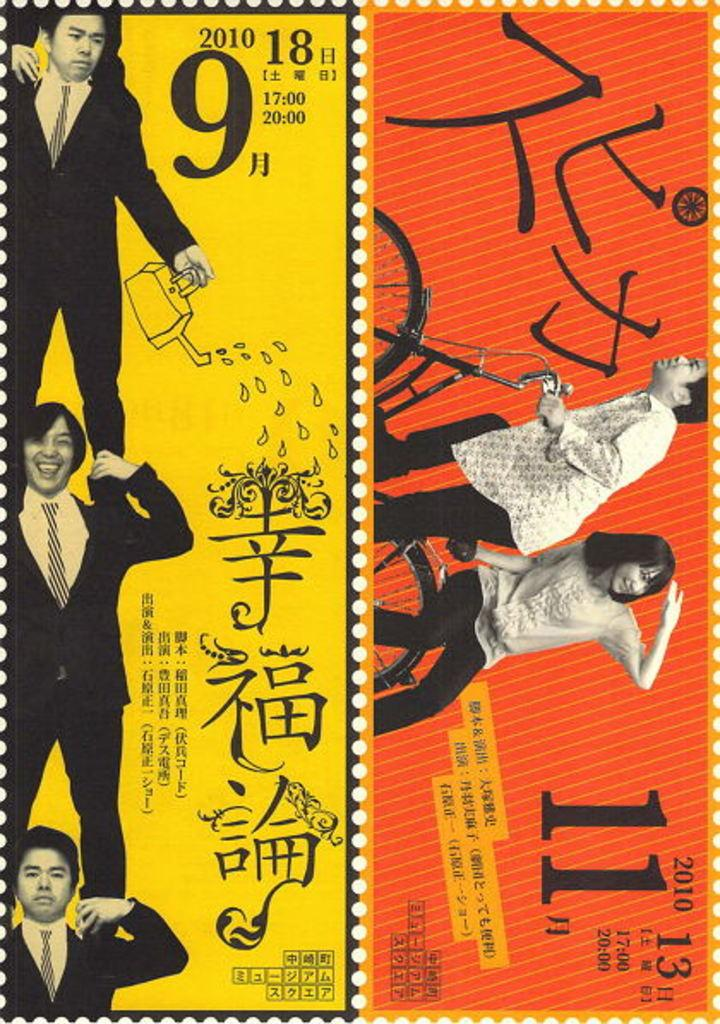<image>
Render a clear and concise summary of the photo. Japanese stamps that shows a man standing next to a large number 9. 